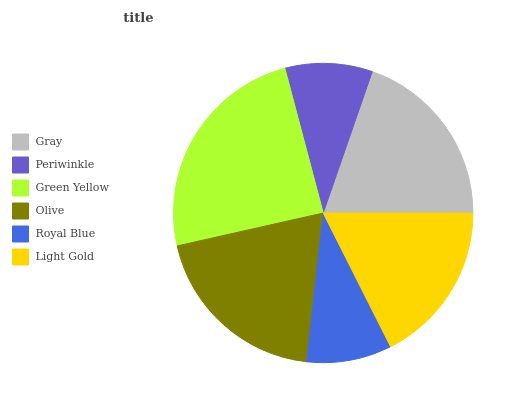Is Royal Blue the minimum?
Answer yes or no. Yes. Is Green Yellow the maximum?
Answer yes or no. Yes. Is Periwinkle the minimum?
Answer yes or no. No. Is Periwinkle the maximum?
Answer yes or no. No. Is Gray greater than Periwinkle?
Answer yes or no. Yes. Is Periwinkle less than Gray?
Answer yes or no. Yes. Is Periwinkle greater than Gray?
Answer yes or no. No. Is Gray less than Periwinkle?
Answer yes or no. No. Is Gray the high median?
Answer yes or no. Yes. Is Light Gold the low median?
Answer yes or no. Yes. Is Green Yellow the high median?
Answer yes or no. No. Is Gray the low median?
Answer yes or no. No. 